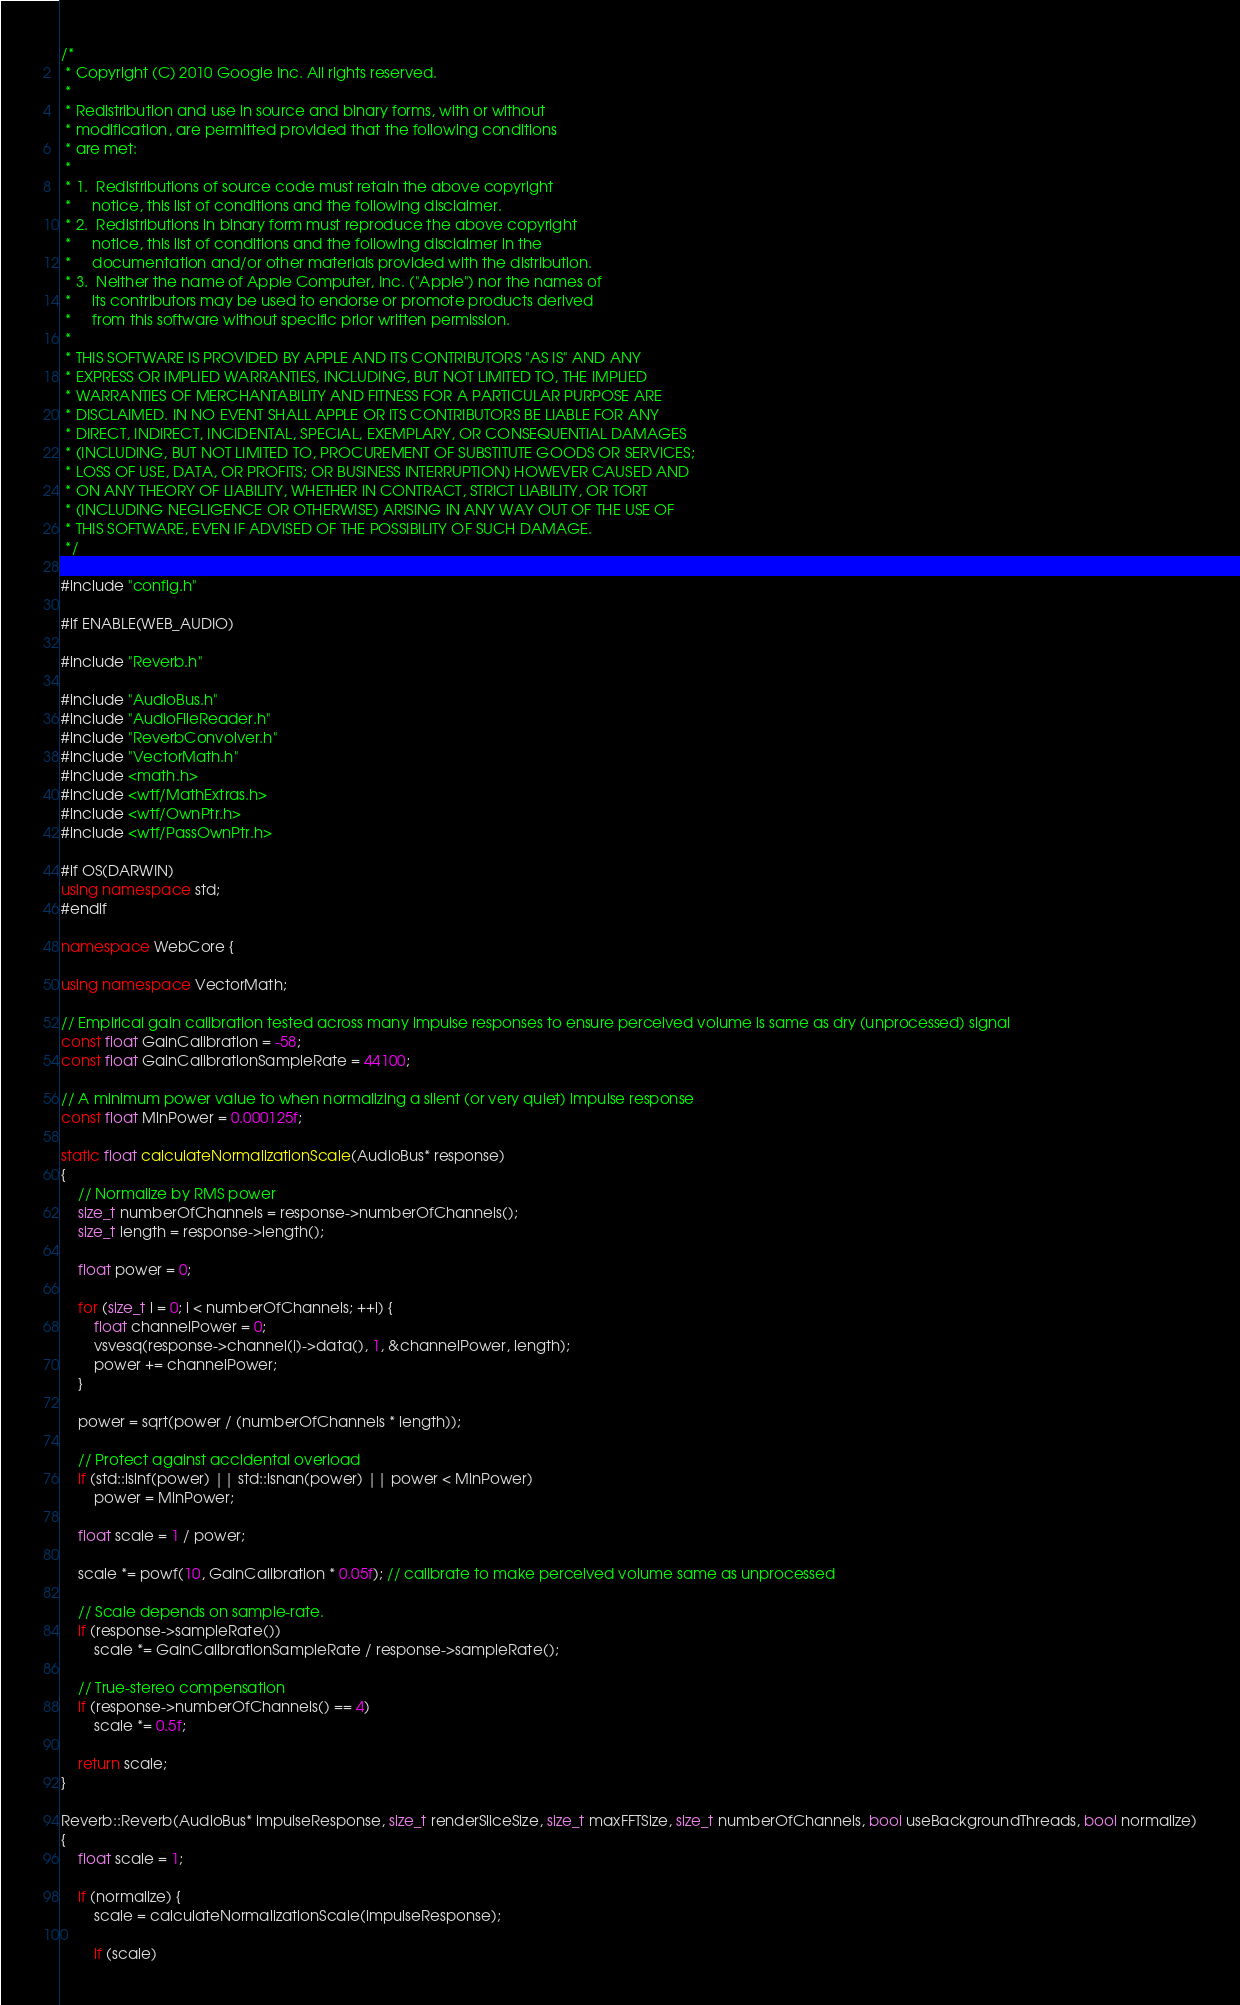Convert code to text. <code><loc_0><loc_0><loc_500><loc_500><_C++_>/*
 * Copyright (C) 2010 Google Inc. All rights reserved.
 *
 * Redistribution and use in source and binary forms, with or without
 * modification, are permitted provided that the following conditions
 * are met:
 *
 * 1.  Redistributions of source code must retain the above copyright
 *     notice, this list of conditions and the following disclaimer.
 * 2.  Redistributions in binary form must reproduce the above copyright
 *     notice, this list of conditions and the following disclaimer in the
 *     documentation and/or other materials provided with the distribution.
 * 3.  Neither the name of Apple Computer, Inc. ("Apple") nor the names of
 *     its contributors may be used to endorse or promote products derived
 *     from this software without specific prior written permission.
 *
 * THIS SOFTWARE IS PROVIDED BY APPLE AND ITS CONTRIBUTORS "AS IS" AND ANY
 * EXPRESS OR IMPLIED WARRANTIES, INCLUDING, BUT NOT LIMITED TO, THE IMPLIED
 * WARRANTIES OF MERCHANTABILITY AND FITNESS FOR A PARTICULAR PURPOSE ARE
 * DISCLAIMED. IN NO EVENT SHALL APPLE OR ITS CONTRIBUTORS BE LIABLE FOR ANY
 * DIRECT, INDIRECT, INCIDENTAL, SPECIAL, EXEMPLARY, OR CONSEQUENTIAL DAMAGES
 * (INCLUDING, BUT NOT LIMITED TO, PROCUREMENT OF SUBSTITUTE GOODS OR SERVICES;
 * LOSS OF USE, DATA, OR PROFITS; OR BUSINESS INTERRUPTION) HOWEVER CAUSED AND
 * ON ANY THEORY OF LIABILITY, WHETHER IN CONTRACT, STRICT LIABILITY, OR TORT
 * (INCLUDING NEGLIGENCE OR OTHERWISE) ARISING IN ANY WAY OUT OF THE USE OF
 * THIS SOFTWARE, EVEN IF ADVISED OF THE POSSIBILITY OF SUCH DAMAGE.
 */

#include "config.h"

#if ENABLE(WEB_AUDIO)

#include "Reverb.h"

#include "AudioBus.h"
#include "AudioFileReader.h"
#include "ReverbConvolver.h"
#include "VectorMath.h"
#include <math.h>
#include <wtf/MathExtras.h>
#include <wtf/OwnPtr.h>
#include <wtf/PassOwnPtr.h>

#if OS(DARWIN)
using namespace std;
#endif

namespace WebCore {

using namespace VectorMath;

// Empirical gain calibration tested across many impulse responses to ensure perceived volume is same as dry (unprocessed) signal
const float GainCalibration = -58;
const float GainCalibrationSampleRate = 44100;

// A minimum power value to when normalizing a silent (or very quiet) impulse response
const float MinPower = 0.000125f;
    
static float calculateNormalizationScale(AudioBus* response)
{
    // Normalize by RMS power
    size_t numberOfChannels = response->numberOfChannels();
    size_t length = response->length();

    float power = 0;

    for (size_t i = 0; i < numberOfChannels; ++i) {
        float channelPower = 0;
        vsvesq(response->channel(i)->data(), 1, &channelPower, length);
        power += channelPower;
    }

    power = sqrt(power / (numberOfChannels * length));

    // Protect against accidental overload
    if (std::isinf(power) || std::isnan(power) || power < MinPower)
        power = MinPower;

    float scale = 1 / power;

    scale *= powf(10, GainCalibration * 0.05f); // calibrate to make perceived volume same as unprocessed

    // Scale depends on sample-rate.
    if (response->sampleRate())
        scale *= GainCalibrationSampleRate / response->sampleRate();

    // True-stereo compensation
    if (response->numberOfChannels() == 4)
        scale *= 0.5f;

    return scale;
}

Reverb::Reverb(AudioBus* impulseResponse, size_t renderSliceSize, size_t maxFFTSize, size_t numberOfChannels, bool useBackgroundThreads, bool normalize)
{
    float scale = 1;

    if (normalize) {
        scale = calculateNormalizationScale(impulseResponse);

        if (scale)</code> 